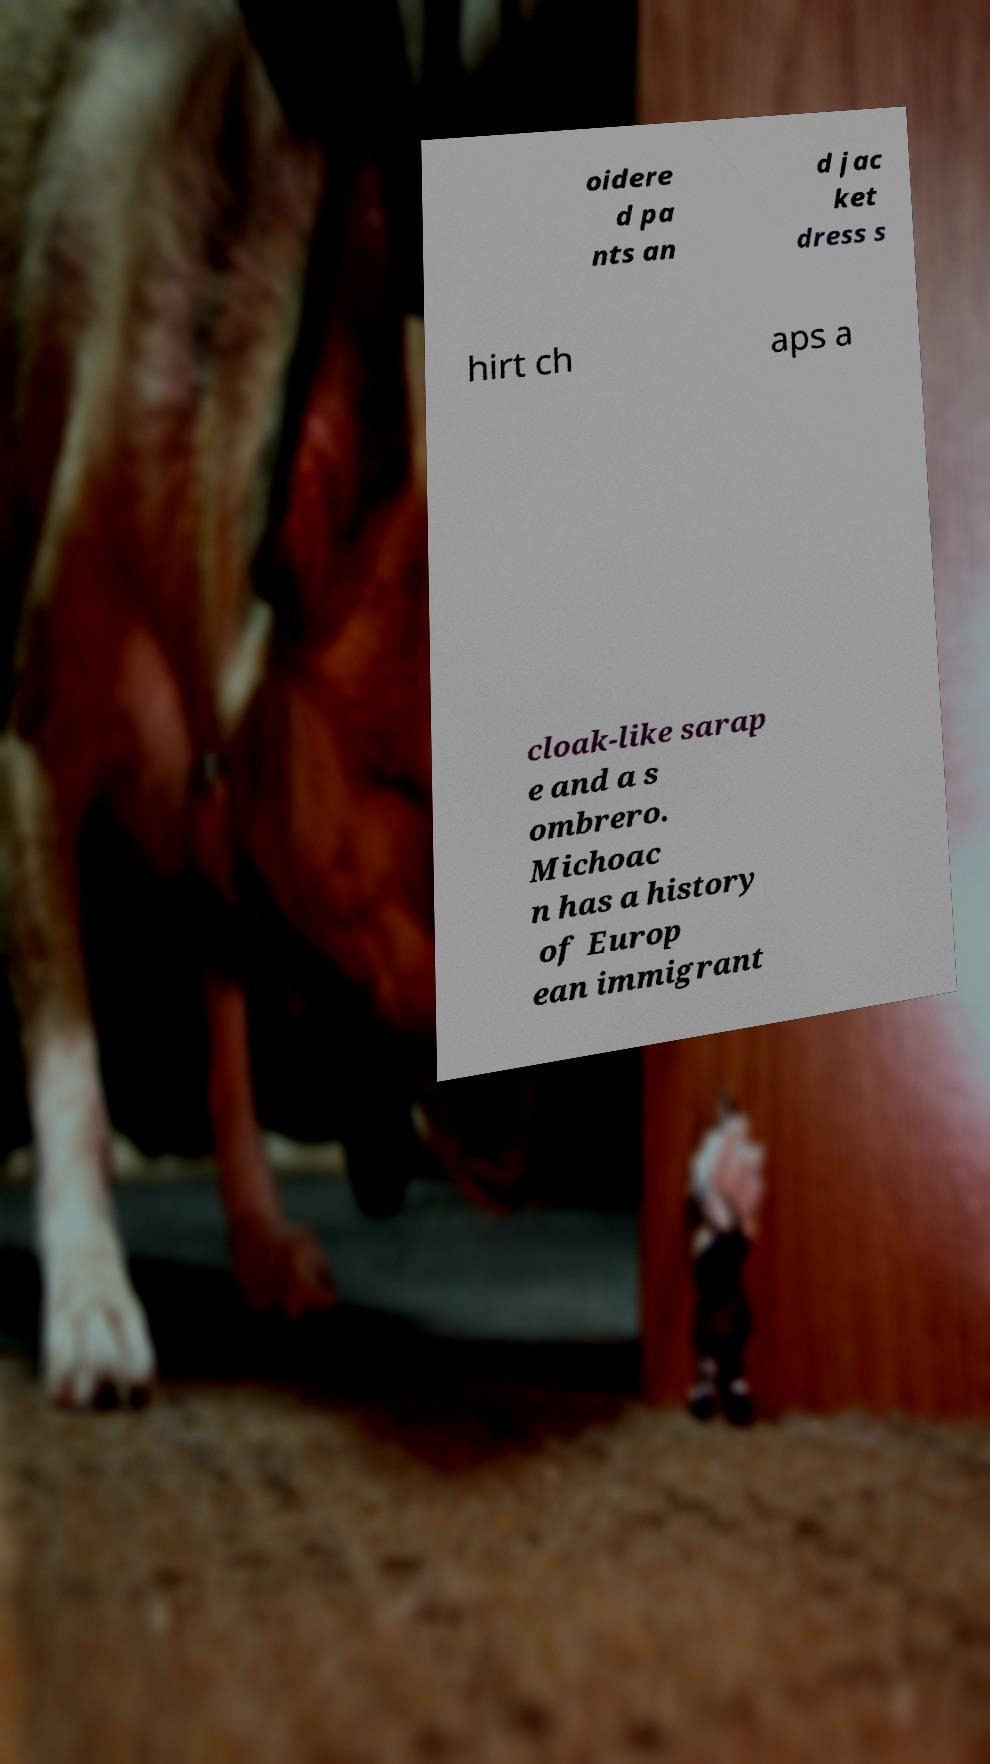I need the written content from this picture converted into text. Can you do that? oidere d pa nts an d jac ket dress s hirt ch aps a cloak-like sarap e and a s ombrero. Michoac n has a history of Europ ean immigrant 